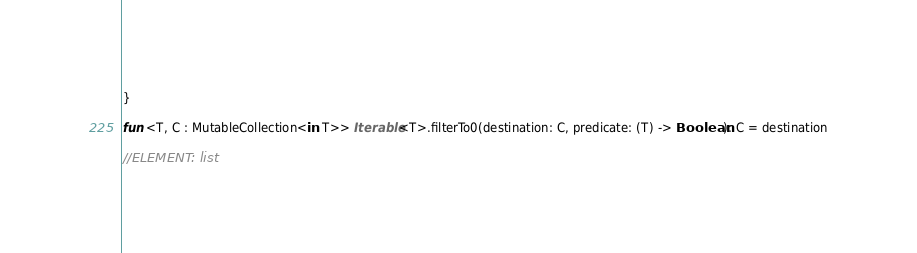Convert code to text. <code><loc_0><loc_0><loc_500><loc_500><_Kotlin_>}

fun <T, C : MutableCollection<in T>> Iterable<T>.filterTo0(destination: C, predicate: (T) -> Boolean): C = destination

//ELEMENT: list</code> 